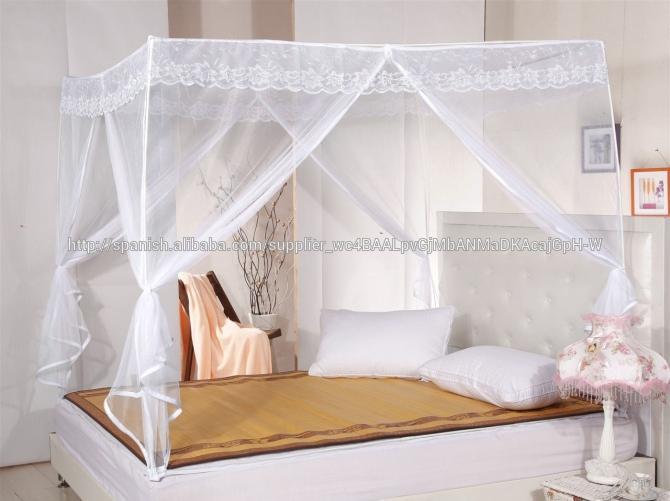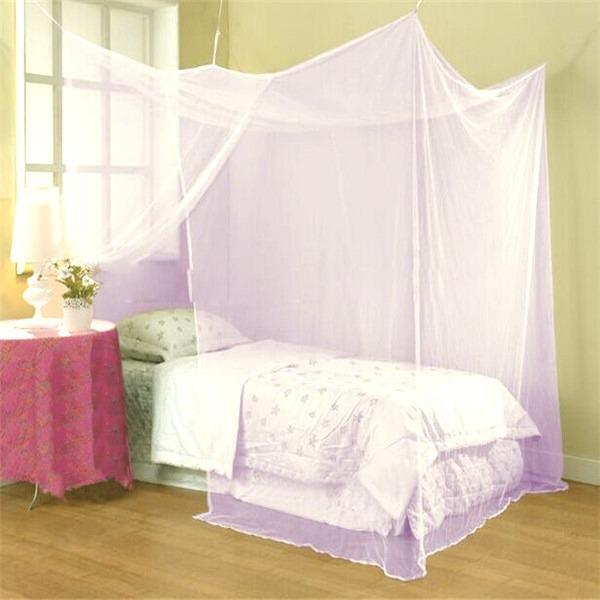The first image is the image on the left, the second image is the image on the right. Examine the images to the left and right. Is the description "Exactly one bed has a round canopy." accurate? Answer yes or no. No. The first image is the image on the left, the second image is the image on the right. Given the left and right images, does the statement "Two or more lamp shades are visible." hold true? Answer yes or no. Yes. 